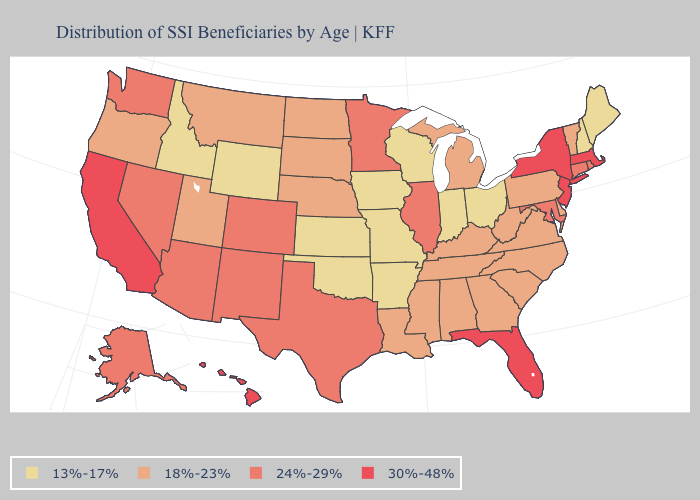What is the lowest value in the MidWest?
Concise answer only. 13%-17%. Which states hav the highest value in the South?
Be succinct. Florida. What is the value of Montana?
Keep it brief. 18%-23%. What is the highest value in the USA?
Answer briefly. 30%-48%. What is the value of Nebraska?
Be succinct. 18%-23%. Which states have the lowest value in the USA?
Give a very brief answer. Arkansas, Idaho, Indiana, Iowa, Kansas, Maine, Missouri, New Hampshire, Ohio, Oklahoma, Wisconsin, Wyoming. Does the first symbol in the legend represent the smallest category?
Answer briefly. Yes. How many symbols are there in the legend?
Answer briefly. 4. What is the value of Kansas?
Quick response, please. 13%-17%. Name the states that have a value in the range 13%-17%?
Keep it brief. Arkansas, Idaho, Indiana, Iowa, Kansas, Maine, Missouri, New Hampshire, Ohio, Oklahoma, Wisconsin, Wyoming. Name the states that have a value in the range 18%-23%?
Give a very brief answer. Alabama, Delaware, Georgia, Kentucky, Louisiana, Michigan, Mississippi, Montana, Nebraska, North Carolina, North Dakota, Oregon, Pennsylvania, South Carolina, South Dakota, Tennessee, Utah, Vermont, Virginia, West Virginia. Name the states that have a value in the range 30%-48%?
Short answer required. California, Florida, Hawaii, Massachusetts, New Jersey, New York. What is the highest value in the Northeast ?
Quick response, please. 30%-48%. Does Colorado have the highest value in the West?
Quick response, please. No. What is the value of Indiana?
Be succinct. 13%-17%. 